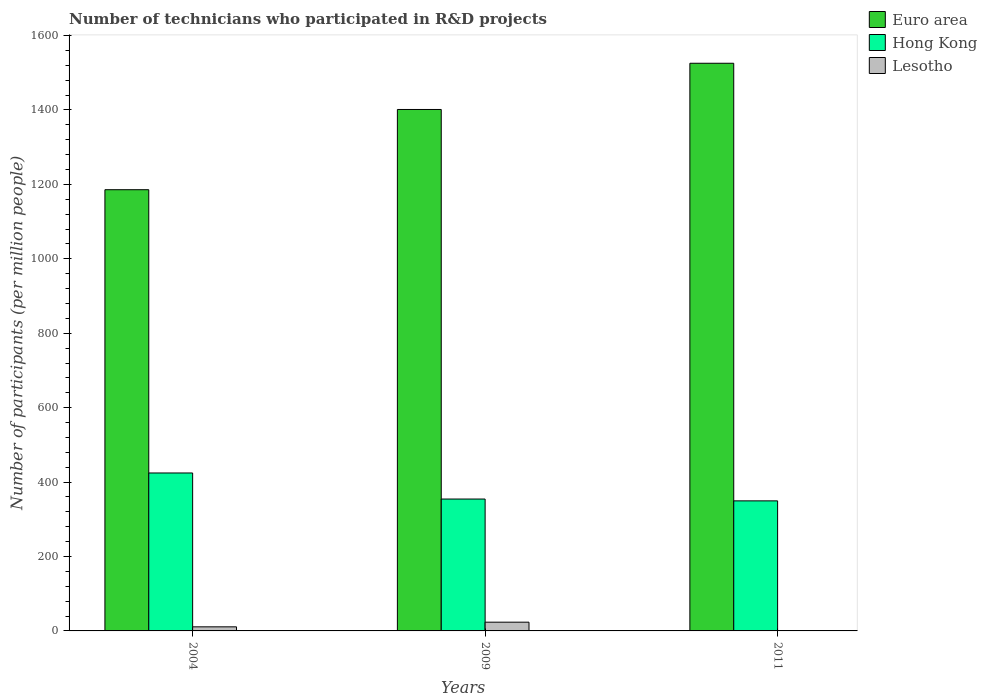How many groups of bars are there?
Your answer should be compact. 3. Are the number of bars on each tick of the X-axis equal?
Give a very brief answer. Yes. How many bars are there on the 1st tick from the right?
Keep it short and to the point. 3. What is the number of technicians who participated in R&D projects in Euro area in 2009?
Keep it short and to the point. 1401.39. Across all years, what is the maximum number of technicians who participated in R&D projects in Lesotho?
Offer a very short reply. 23.51. Across all years, what is the minimum number of technicians who participated in R&D projects in Euro area?
Ensure brevity in your answer.  1185.77. In which year was the number of technicians who participated in R&D projects in Lesotho minimum?
Provide a succinct answer. 2011. What is the total number of technicians who participated in R&D projects in Hong Kong in the graph?
Your answer should be compact. 1128.39. What is the difference between the number of technicians who participated in R&D projects in Euro area in 2009 and that in 2011?
Your answer should be compact. -124.2. What is the difference between the number of technicians who participated in R&D projects in Lesotho in 2009 and the number of technicians who participated in R&D projects in Euro area in 2004?
Your answer should be very brief. -1162.25. What is the average number of technicians who participated in R&D projects in Euro area per year?
Your answer should be very brief. 1370.91. In the year 2004, what is the difference between the number of technicians who participated in R&D projects in Lesotho and number of technicians who participated in R&D projects in Hong Kong?
Make the answer very short. -413.47. What is the ratio of the number of technicians who participated in R&D projects in Lesotho in 2009 to that in 2011?
Provide a succinct answer. 26.56. Is the number of technicians who participated in R&D projects in Euro area in 2004 less than that in 2011?
Provide a short and direct response. Yes. What is the difference between the highest and the second highest number of technicians who participated in R&D projects in Hong Kong?
Offer a terse response. 70.03. What is the difference between the highest and the lowest number of technicians who participated in R&D projects in Euro area?
Ensure brevity in your answer.  339.82. What does the 3rd bar from the left in 2004 represents?
Ensure brevity in your answer.  Lesotho. What does the 1st bar from the right in 2009 represents?
Your answer should be compact. Lesotho. How many years are there in the graph?
Ensure brevity in your answer.  3. What is the difference between two consecutive major ticks on the Y-axis?
Your answer should be very brief. 200. Are the values on the major ticks of Y-axis written in scientific E-notation?
Provide a succinct answer. No. Where does the legend appear in the graph?
Your answer should be very brief. Top right. How are the legend labels stacked?
Your answer should be very brief. Vertical. What is the title of the graph?
Your response must be concise. Number of technicians who participated in R&D projects. Does "Mali" appear as one of the legend labels in the graph?
Give a very brief answer. No. What is the label or title of the Y-axis?
Offer a very short reply. Number of participants (per million people). What is the Number of participants (per million people) of Euro area in 2004?
Your answer should be compact. 1185.77. What is the Number of participants (per million people) of Hong Kong in 2004?
Offer a terse response. 424.46. What is the Number of participants (per million people) of Lesotho in 2004?
Keep it short and to the point. 10.98. What is the Number of participants (per million people) in Euro area in 2009?
Make the answer very short. 1401.39. What is the Number of participants (per million people) in Hong Kong in 2009?
Give a very brief answer. 354.43. What is the Number of participants (per million people) of Lesotho in 2009?
Keep it short and to the point. 23.51. What is the Number of participants (per million people) in Euro area in 2011?
Give a very brief answer. 1525.59. What is the Number of participants (per million people) in Hong Kong in 2011?
Provide a succinct answer. 349.51. What is the Number of participants (per million people) of Lesotho in 2011?
Your answer should be compact. 0.89. Across all years, what is the maximum Number of participants (per million people) of Euro area?
Ensure brevity in your answer.  1525.59. Across all years, what is the maximum Number of participants (per million people) in Hong Kong?
Offer a terse response. 424.46. Across all years, what is the maximum Number of participants (per million people) in Lesotho?
Give a very brief answer. 23.51. Across all years, what is the minimum Number of participants (per million people) in Euro area?
Your answer should be very brief. 1185.77. Across all years, what is the minimum Number of participants (per million people) of Hong Kong?
Your answer should be compact. 349.51. Across all years, what is the minimum Number of participants (per million people) of Lesotho?
Provide a short and direct response. 0.89. What is the total Number of participants (per million people) of Euro area in the graph?
Make the answer very short. 4112.74. What is the total Number of participants (per million people) of Hong Kong in the graph?
Make the answer very short. 1128.39. What is the total Number of participants (per million people) of Lesotho in the graph?
Offer a terse response. 35.38. What is the difference between the Number of participants (per million people) in Euro area in 2004 and that in 2009?
Make the answer very short. -215.63. What is the difference between the Number of participants (per million people) of Hong Kong in 2004 and that in 2009?
Offer a terse response. 70.03. What is the difference between the Number of participants (per million people) of Lesotho in 2004 and that in 2009?
Offer a very short reply. -12.53. What is the difference between the Number of participants (per million people) of Euro area in 2004 and that in 2011?
Offer a very short reply. -339.82. What is the difference between the Number of participants (per million people) of Hong Kong in 2004 and that in 2011?
Your answer should be very brief. 74.95. What is the difference between the Number of participants (per million people) in Lesotho in 2004 and that in 2011?
Provide a short and direct response. 10.1. What is the difference between the Number of participants (per million people) in Euro area in 2009 and that in 2011?
Keep it short and to the point. -124.2. What is the difference between the Number of participants (per million people) of Hong Kong in 2009 and that in 2011?
Offer a very short reply. 4.92. What is the difference between the Number of participants (per million people) in Lesotho in 2009 and that in 2011?
Make the answer very short. 22.63. What is the difference between the Number of participants (per million people) of Euro area in 2004 and the Number of participants (per million people) of Hong Kong in 2009?
Give a very brief answer. 831.34. What is the difference between the Number of participants (per million people) in Euro area in 2004 and the Number of participants (per million people) in Lesotho in 2009?
Provide a short and direct response. 1162.25. What is the difference between the Number of participants (per million people) in Hong Kong in 2004 and the Number of participants (per million people) in Lesotho in 2009?
Offer a very short reply. 400.94. What is the difference between the Number of participants (per million people) of Euro area in 2004 and the Number of participants (per million people) of Hong Kong in 2011?
Keep it short and to the point. 836.26. What is the difference between the Number of participants (per million people) in Euro area in 2004 and the Number of participants (per million people) in Lesotho in 2011?
Make the answer very short. 1184.88. What is the difference between the Number of participants (per million people) of Hong Kong in 2004 and the Number of participants (per million people) of Lesotho in 2011?
Provide a short and direct response. 423.57. What is the difference between the Number of participants (per million people) in Euro area in 2009 and the Number of participants (per million people) in Hong Kong in 2011?
Your answer should be compact. 1051.88. What is the difference between the Number of participants (per million people) of Euro area in 2009 and the Number of participants (per million people) of Lesotho in 2011?
Ensure brevity in your answer.  1400.51. What is the difference between the Number of participants (per million people) in Hong Kong in 2009 and the Number of participants (per million people) in Lesotho in 2011?
Provide a short and direct response. 353.54. What is the average Number of participants (per million people) in Euro area per year?
Keep it short and to the point. 1370.91. What is the average Number of participants (per million people) of Hong Kong per year?
Offer a very short reply. 376.13. What is the average Number of participants (per million people) of Lesotho per year?
Your answer should be compact. 11.79. In the year 2004, what is the difference between the Number of participants (per million people) of Euro area and Number of participants (per million people) of Hong Kong?
Ensure brevity in your answer.  761.31. In the year 2004, what is the difference between the Number of participants (per million people) of Euro area and Number of participants (per million people) of Lesotho?
Ensure brevity in your answer.  1174.78. In the year 2004, what is the difference between the Number of participants (per million people) in Hong Kong and Number of participants (per million people) in Lesotho?
Your response must be concise. 413.47. In the year 2009, what is the difference between the Number of participants (per million people) in Euro area and Number of participants (per million people) in Hong Kong?
Offer a terse response. 1046.97. In the year 2009, what is the difference between the Number of participants (per million people) in Euro area and Number of participants (per million people) in Lesotho?
Give a very brief answer. 1377.88. In the year 2009, what is the difference between the Number of participants (per million people) in Hong Kong and Number of participants (per million people) in Lesotho?
Make the answer very short. 330.91. In the year 2011, what is the difference between the Number of participants (per million people) in Euro area and Number of participants (per million people) in Hong Kong?
Provide a succinct answer. 1176.08. In the year 2011, what is the difference between the Number of participants (per million people) of Euro area and Number of participants (per million people) of Lesotho?
Give a very brief answer. 1524.7. In the year 2011, what is the difference between the Number of participants (per million people) of Hong Kong and Number of participants (per million people) of Lesotho?
Ensure brevity in your answer.  348.62. What is the ratio of the Number of participants (per million people) in Euro area in 2004 to that in 2009?
Your response must be concise. 0.85. What is the ratio of the Number of participants (per million people) of Hong Kong in 2004 to that in 2009?
Your response must be concise. 1.2. What is the ratio of the Number of participants (per million people) in Lesotho in 2004 to that in 2009?
Keep it short and to the point. 0.47. What is the ratio of the Number of participants (per million people) of Euro area in 2004 to that in 2011?
Provide a short and direct response. 0.78. What is the ratio of the Number of participants (per million people) in Hong Kong in 2004 to that in 2011?
Provide a short and direct response. 1.21. What is the ratio of the Number of participants (per million people) of Lesotho in 2004 to that in 2011?
Your answer should be compact. 12.4. What is the ratio of the Number of participants (per million people) in Euro area in 2009 to that in 2011?
Provide a short and direct response. 0.92. What is the ratio of the Number of participants (per million people) in Hong Kong in 2009 to that in 2011?
Offer a very short reply. 1.01. What is the ratio of the Number of participants (per million people) in Lesotho in 2009 to that in 2011?
Your response must be concise. 26.56. What is the difference between the highest and the second highest Number of participants (per million people) of Euro area?
Make the answer very short. 124.2. What is the difference between the highest and the second highest Number of participants (per million people) of Hong Kong?
Your answer should be compact. 70.03. What is the difference between the highest and the second highest Number of participants (per million people) in Lesotho?
Make the answer very short. 12.53. What is the difference between the highest and the lowest Number of participants (per million people) in Euro area?
Your answer should be very brief. 339.82. What is the difference between the highest and the lowest Number of participants (per million people) of Hong Kong?
Provide a short and direct response. 74.95. What is the difference between the highest and the lowest Number of participants (per million people) of Lesotho?
Ensure brevity in your answer.  22.63. 